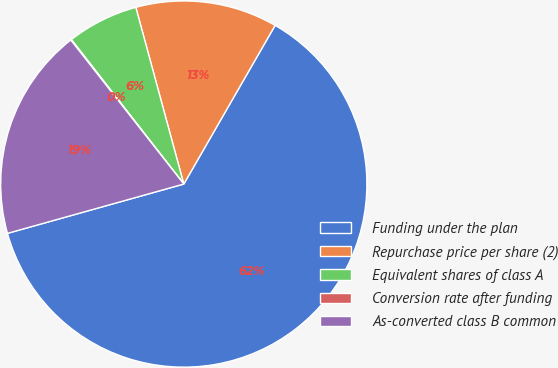Convert chart to OTSL. <chart><loc_0><loc_0><loc_500><loc_500><pie_chart><fcel>Funding under the plan<fcel>Repurchase price per share (2)<fcel>Equivalent shares of class A<fcel>Conversion rate after funding<fcel>As-converted class B common<nl><fcel>62.35%<fcel>12.53%<fcel>6.3%<fcel>0.07%<fcel>18.75%<nl></chart> 